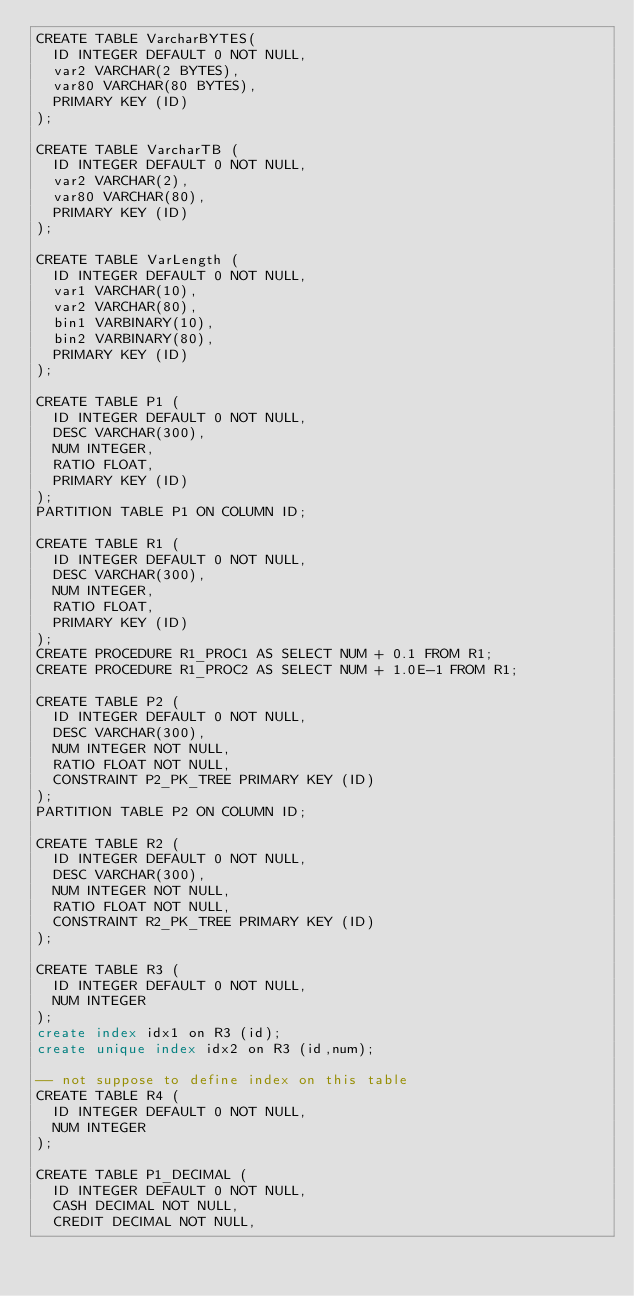<code> <loc_0><loc_0><loc_500><loc_500><_SQL_>CREATE TABLE VarcharBYTES(
  ID INTEGER DEFAULT 0 NOT NULL,
  var2 VARCHAR(2 BYTES),
  var80 VARCHAR(80 BYTES),
  PRIMARY KEY (ID)
);

CREATE TABLE VarcharTB (
  ID INTEGER DEFAULT 0 NOT NULL,
  var2 VARCHAR(2),
  var80 VARCHAR(80),
  PRIMARY KEY (ID)
);

CREATE TABLE VarLength (
  ID INTEGER DEFAULT 0 NOT NULL,
  var1 VARCHAR(10),
  var2 VARCHAR(80),
  bin1 VARBINARY(10),
  bin2 VARBINARY(80),
  PRIMARY KEY (ID)
);

CREATE TABLE P1 (
  ID INTEGER DEFAULT 0 NOT NULL,
  DESC VARCHAR(300),
  NUM INTEGER,
  RATIO FLOAT,
  PRIMARY KEY (ID)
);
PARTITION TABLE P1 ON COLUMN ID;

CREATE TABLE R1 (
  ID INTEGER DEFAULT 0 NOT NULL,
  DESC VARCHAR(300),
  NUM INTEGER,
  RATIO FLOAT,
  PRIMARY KEY (ID)
);
CREATE PROCEDURE R1_PROC1 AS SELECT NUM + 0.1 FROM R1;
CREATE PROCEDURE R1_PROC2 AS SELECT NUM + 1.0E-1 FROM R1;

CREATE TABLE P2 (
  ID INTEGER DEFAULT 0 NOT NULL,
  DESC VARCHAR(300),
  NUM INTEGER NOT NULL,
  RATIO FLOAT NOT NULL,
  CONSTRAINT P2_PK_TREE PRIMARY KEY (ID)
);
PARTITION TABLE P2 ON COLUMN ID;

CREATE TABLE R2 (
  ID INTEGER DEFAULT 0 NOT NULL,
  DESC VARCHAR(300),
  NUM INTEGER NOT NULL,
  RATIO FLOAT NOT NULL,
  CONSTRAINT R2_PK_TREE PRIMARY KEY (ID)
);

CREATE TABLE R3 (
  ID INTEGER DEFAULT 0 NOT NULL,
  NUM INTEGER
);
create index idx1 on R3 (id);
create unique index idx2 on R3 (id,num);

-- not suppose to define index on this table
CREATE TABLE R4 (
  ID INTEGER DEFAULT 0 NOT NULL,
  NUM INTEGER
);

CREATE TABLE P1_DECIMAL (
  ID INTEGER DEFAULT 0 NOT NULL,
  CASH DECIMAL NOT NULL,
  CREDIT DECIMAL NOT NULL,</code> 